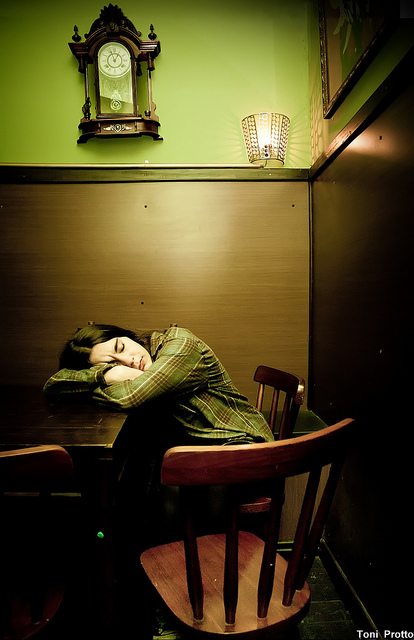Please identify all text content in this image. Protto Toni 